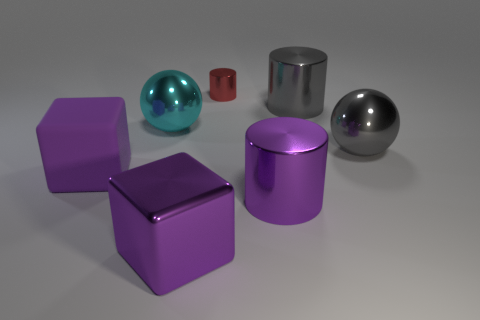Subtract all cyan cylinders. Subtract all purple balls. How many cylinders are left? 3 Add 2 red metallic objects. How many objects exist? 9 Subtract all balls. How many objects are left? 5 Subtract all purple metal blocks. Subtract all cubes. How many objects are left? 4 Add 6 gray metallic cylinders. How many gray metallic cylinders are left? 7 Add 2 purple cylinders. How many purple cylinders exist? 3 Subtract 0 cyan cylinders. How many objects are left? 7 